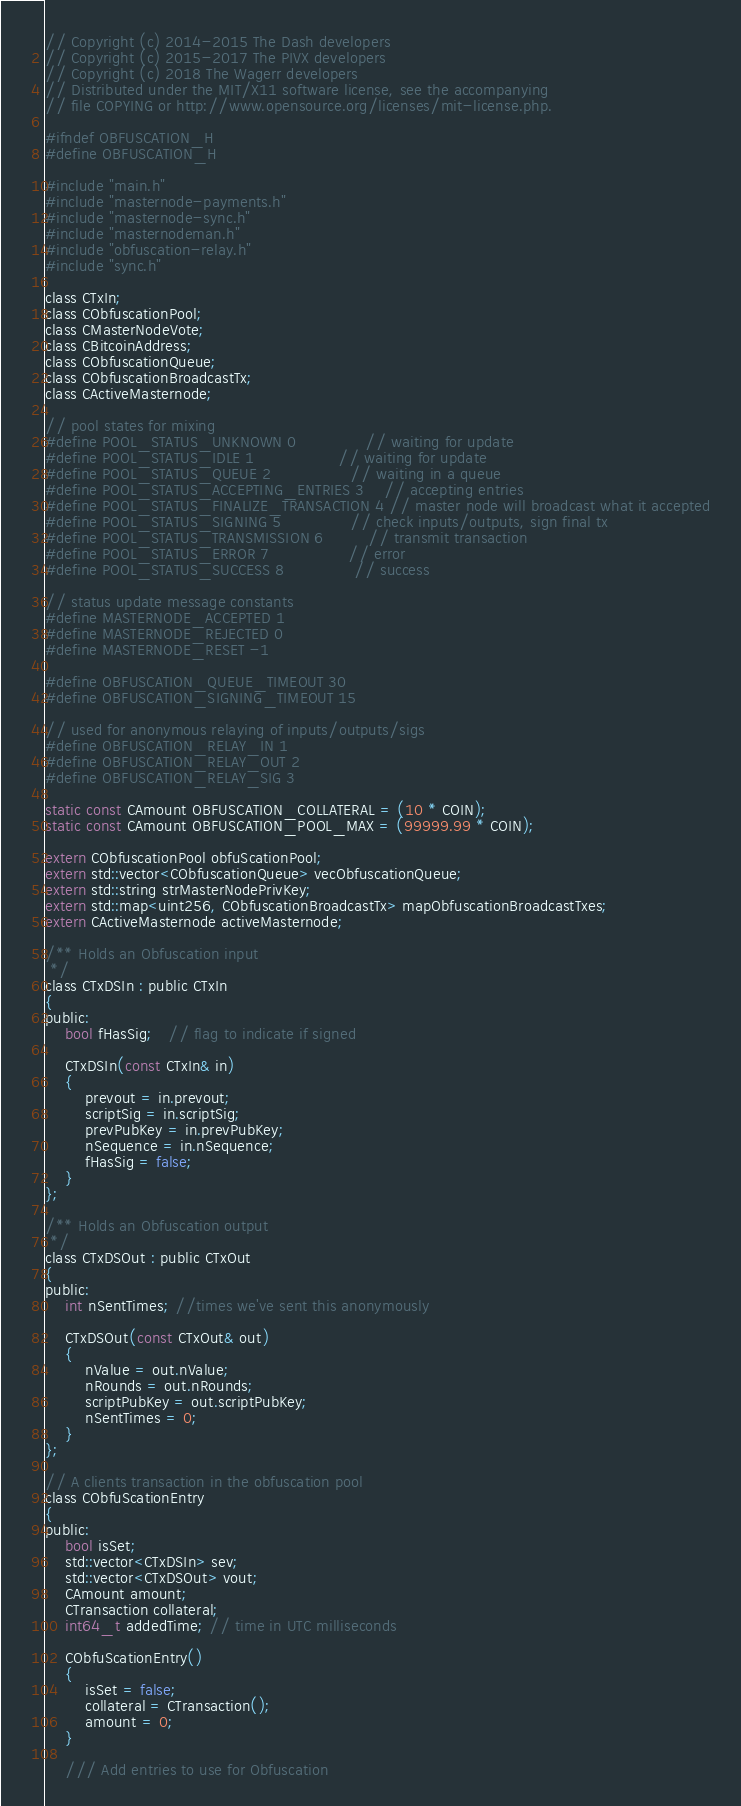Convert code to text. <code><loc_0><loc_0><loc_500><loc_500><_C_>// Copyright (c) 2014-2015 The Dash developers
// Copyright (c) 2015-2017 The PIVX developers
// Copyright (c) 2018 The Wagerr developers
// Distributed under the MIT/X11 software license, see the accompanying
// file COPYING or http://www.opensource.org/licenses/mit-license.php.

#ifndef OBFUSCATION_H
#define OBFUSCATION_H

#include "main.h"
#include "masternode-payments.h"
#include "masternode-sync.h"
#include "masternodeman.h"
#include "obfuscation-relay.h"
#include "sync.h"

class CTxIn;
class CObfuscationPool;
class CMasterNodeVote;
class CBitcoinAddress;
class CObfuscationQueue;
class CObfuscationBroadcastTx;
class CActiveMasternode;

// pool states for mixing
#define POOL_STATUS_UNKNOWN 0              // waiting for update
#define POOL_STATUS_IDLE 1                 // waiting for update
#define POOL_STATUS_QUEUE 2                // waiting in a queue
#define POOL_STATUS_ACCEPTING_ENTRIES 3    // accepting entries
#define POOL_STATUS_FINALIZE_TRANSACTION 4 // master node will broadcast what it accepted
#define POOL_STATUS_SIGNING 5              // check inputs/outputs, sign final tx
#define POOL_STATUS_TRANSMISSION 6         // transmit transaction
#define POOL_STATUS_ERROR 7                // error
#define POOL_STATUS_SUCCESS 8              // success

// status update message constants
#define MASTERNODE_ACCEPTED 1
#define MASTERNODE_REJECTED 0
#define MASTERNODE_RESET -1

#define OBFUSCATION_QUEUE_TIMEOUT 30
#define OBFUSCATION_SIGNING_TIMEOUT 15

// used for anonymous relaying of inputs/outputs/sigs
#define OBFUSCATION_RELAY_IN 1
#define OBFUSCATION_RELAY_OUT 2
#define OBFUSCATION_RELAY_SIG 3

static const CAmount OBFUSCATION_COLLATERAL = (10 * COIN);
static const CAmount OBFUSCATION_POOL_MAX = (99999.99 * COIN);

extern CObfuscationPool obfuScationPool;
extern std::vector<CObfuscationQueue> vecObfuscationQueue;
extern std::string strMasterNodePrivKey;
extern std::map<uint256, CObfuscationBroadcastTx> mapObfuscationBroadcastTxes;
extern CActiveMasternode activeMasternode;

/** Holds an Obfuscation input
 */
class CTxDSIn : public CTxIn
{
public:
    bool fHasSig;   // flag to indicate if signed

    CTxDSIn(const CTxIn& in)
    {
        prevout = in.prevout;
        scriptSig = in.scriptSig;
        prevPubKey = in.prevPubKey;
        nSequence = in.nSequence;
        fHasSig = false;
    }
};

/** Holds an Obfuscation output
 */
class CTxDSOut : public CTxOut
{
public:
    int nSentTimes; //times we've sent this anonymously

    CTxDSOut(const CTxOut& out)
    {
        nValue = out.nValue;
        nRounds = out.nRounds;
        scriptPubKey = out.scriptPubKey;
        nSentTimes = 0;
    }
};

// A clients transaction in the obfuscation pool
class CObfuScationEntry
{
public:
    bool isSet;
    std::vector<CTxDSIn> sev;
    std::vector<CTxDSOut> vout;
    CAmount amount;
    CTransaction collateral;
    int64_t addedTime; // time in UTC milliseconds

    CObfuScationEntry()
    {
        isSet = false;
        collateral = CTransaction();
        amount = 0;
    }

    /// Add entries to use for Obfuscation</code> 